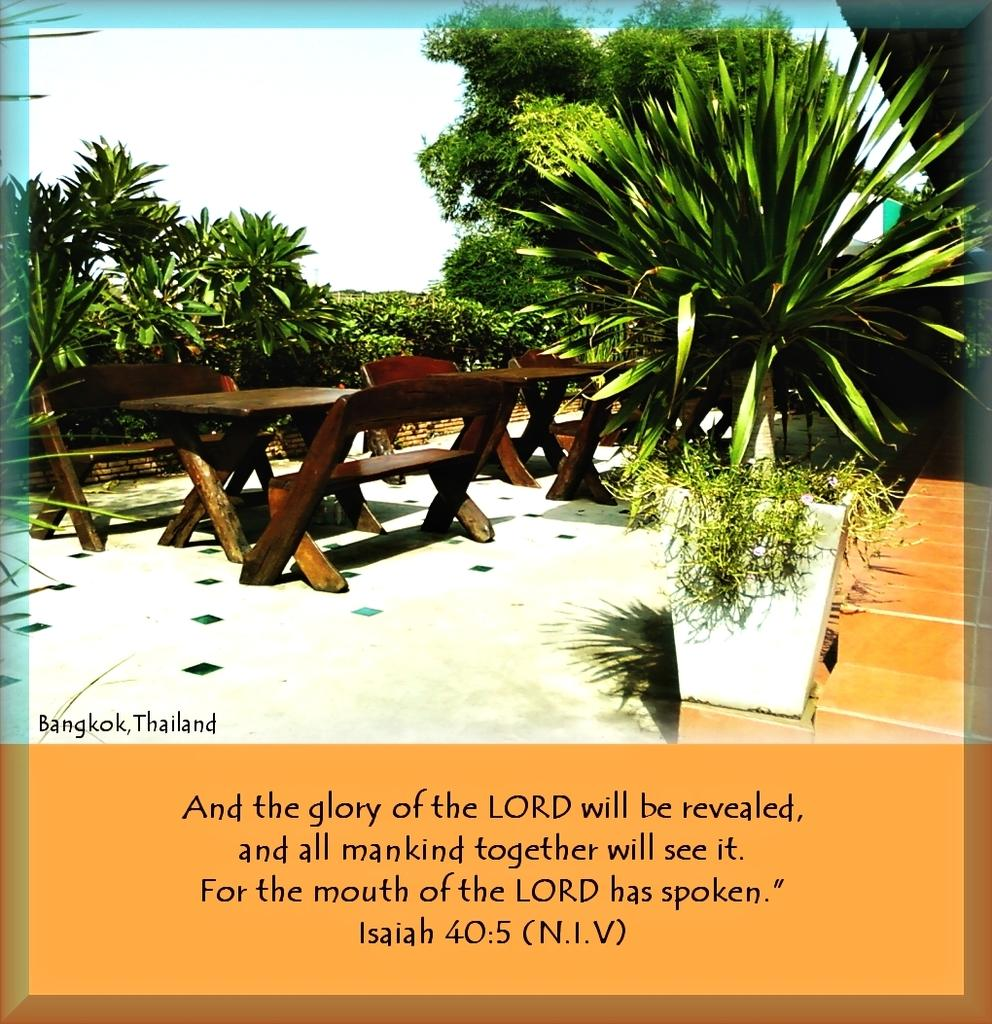What is depicted on the poster in the image? The poster contains tables, benches, trees, plants, and sky. What is the purpose of the text at the bottom of the image? The text at the bottom of the image provides additional information or context about the poster. Can you tell me how many boots are shown in the image? There are no boots present in the image; it features a poster with various elements, including tables, benches, trees, plants, and sky. What type of joke is being told in the image? There is no joke present in the image; it features a poster with various elements and text at the bottom. 